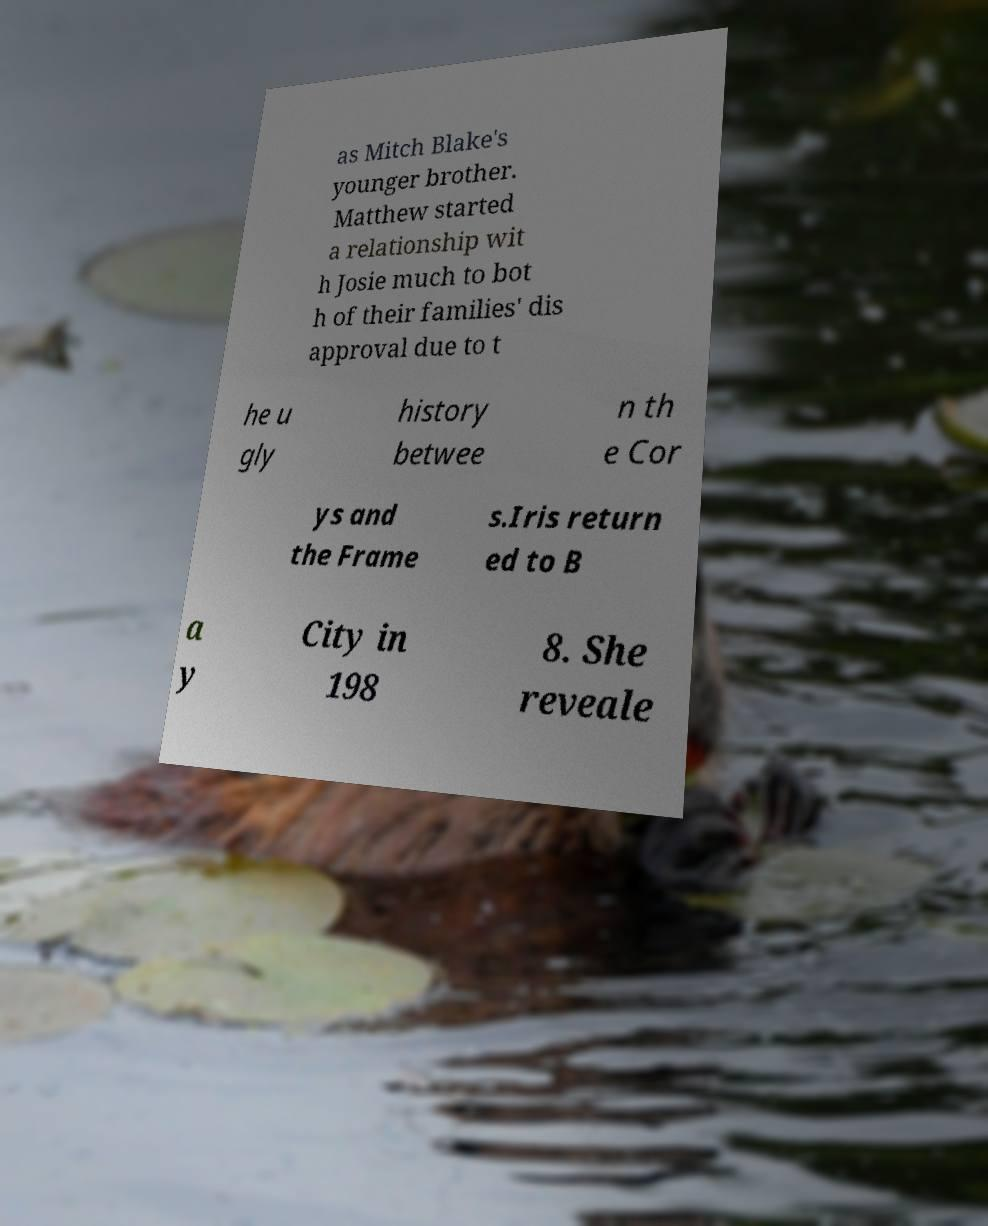Could you extract and type out the text from this image? as Mitch Blake's younger brother. Matthew started a relationship wit h Josie much to bot h of their families' dis approval due to t he u gly history betwee n th e Cor ys and the Frame s.Iris return ed to B a y City in 198 8. She reveale 